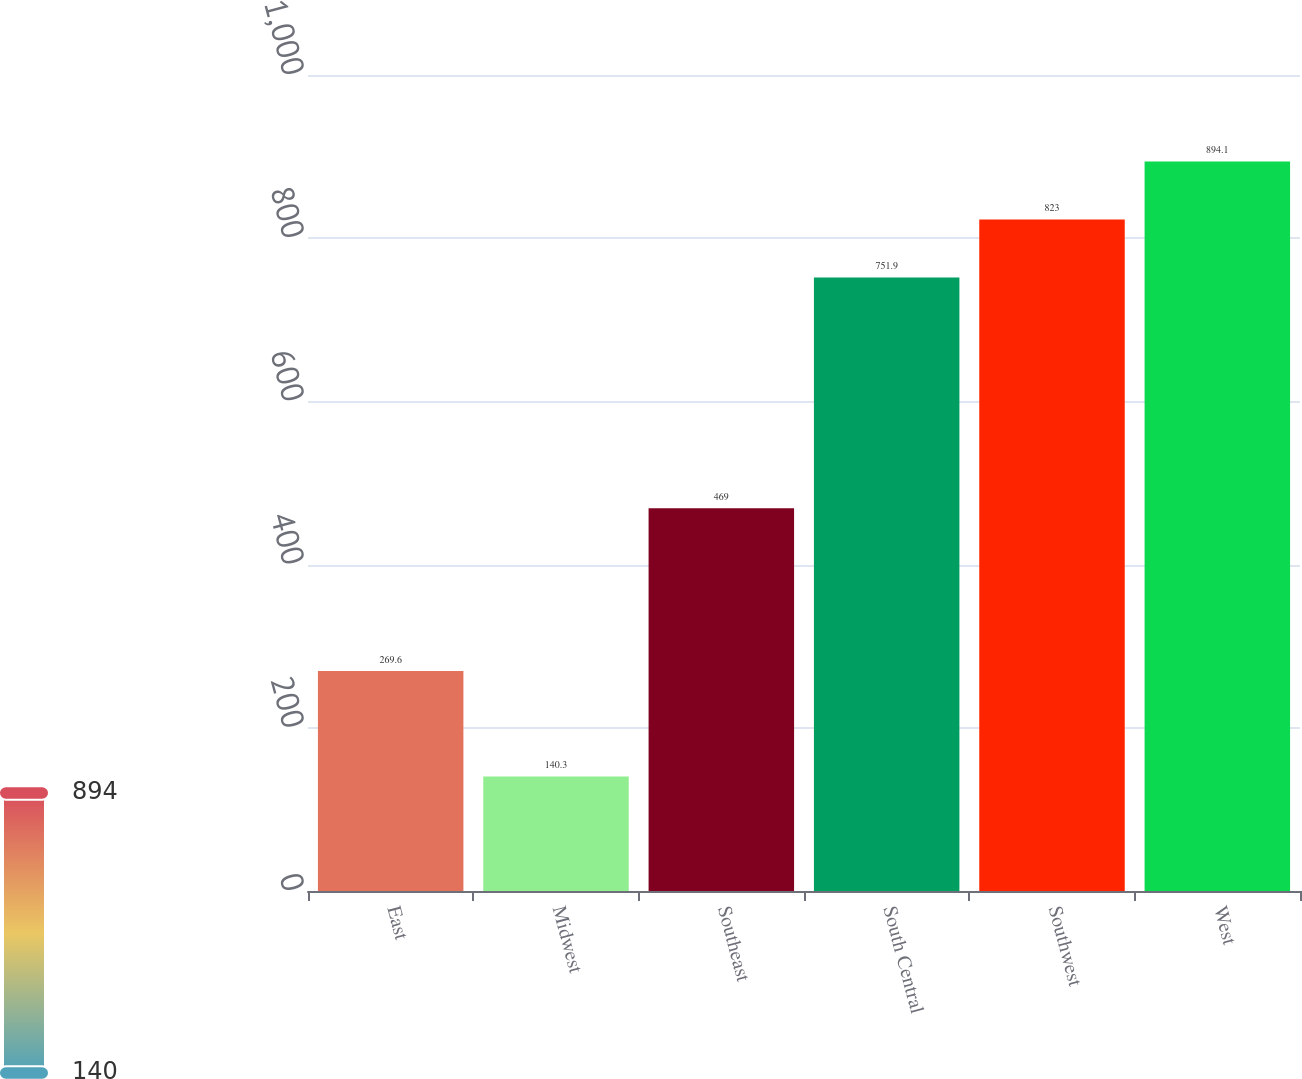Convert chart to OTSL. <chart><loc_0><loc_0><loc_500><loc_500><bar_chart><fcel>East<fcel>Midwest<fcel>Southeast<fcel>South Central<fcel>Southwest<fcel>West<nl><fcel>269.6<fcel>140.3<fcel>469<fcel>751.9<fcel>823<fcel>894.1<nl></chart> 